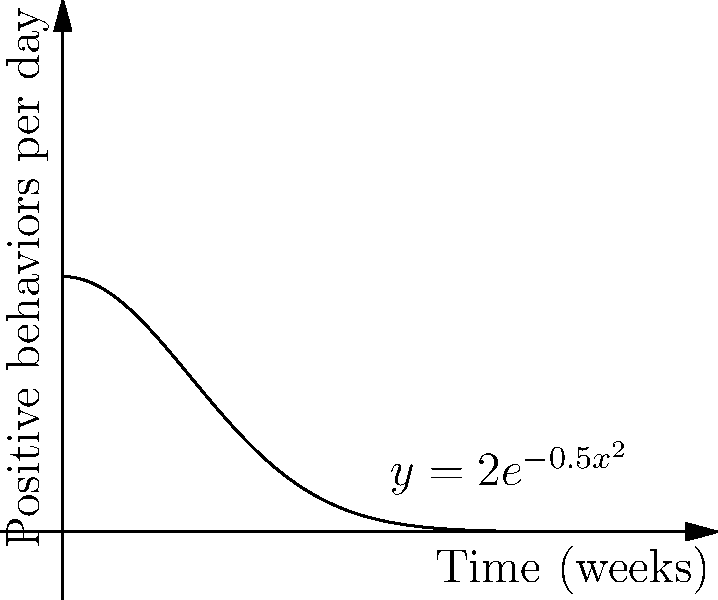A troubled youth's progress in therapy is monitored by tracking the frequency of positive behaviors per day. The curve $y=2e^{-0.5x^2}$ represents this frequency over time, where $x$ is the number of weeks since therapy began. Calculate the total number of positive behaviors exhibited over the first 4 weeks of therapy. To find the total number of positive behaviors over 4 weeks, we need to calculate the area under the curve from $x=0$ to $x=4$. This can be done using a definite integral:

1) Set up the integral: $$\int_0^4 2e^{-0.5x^2} dx$$

2) This integral cannot be solved using elementary antiderivatives. We need to use numerical integration methods or special functions.

3) The solution involves the error function (erf):
   $$\int_0^4 2e^{-0.5x^2} dx = 2\sqrt{\frac{\pi}{2}} \cdot \text{erf}\left(\frac{4}{\sqrt{2}}\right)$$

4) Evaluating this:
   $$2\sqrt{\frac{\pi}{2}} \cdot \text{erf}\left(\frac{4}{\sqrt{2}}\right) \approx 3.5449$$

5) This result represents the total number of positive behaviors over 4 weeks.

Note: In a therapeutic context, we would round this to a whole number, as fractional behaviors don't make practical sense.
Answer: Approximately 35 positive behaviors 